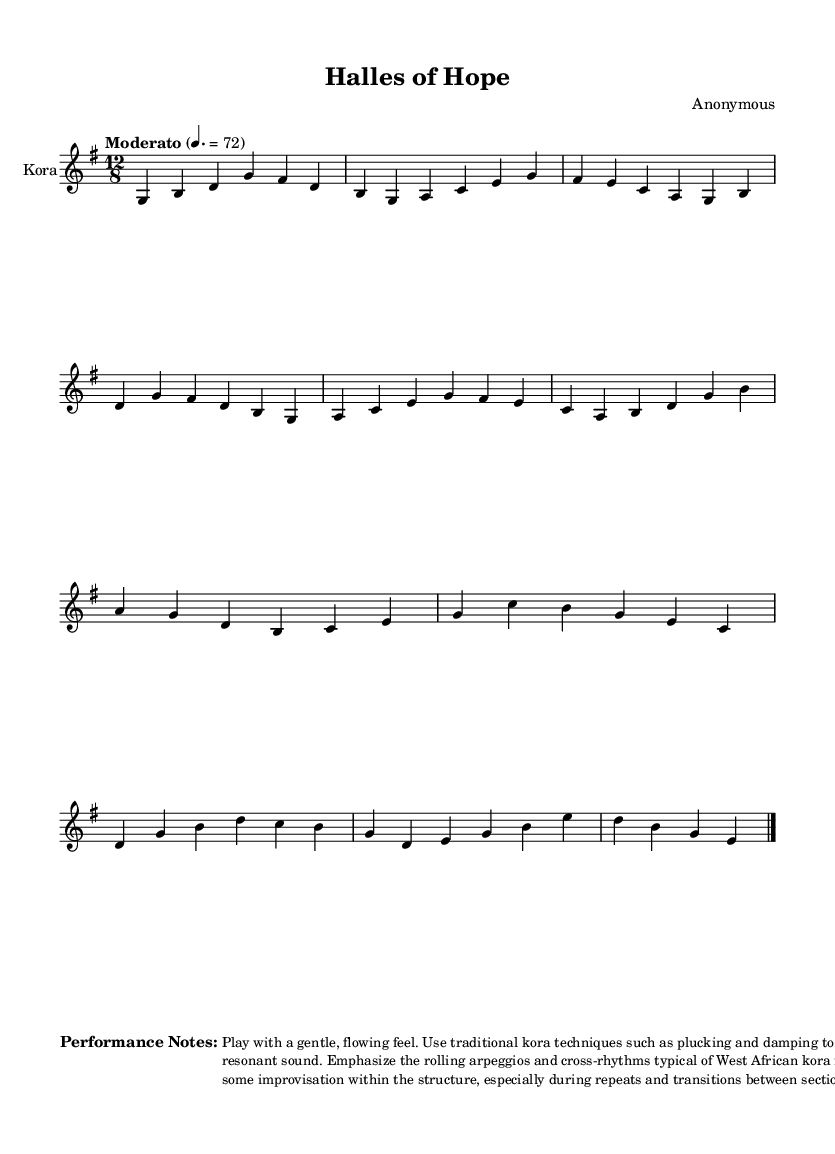What is the key signature of this music? The key signature is G major, which has one sharp (F#). This can be determined by looking at the key signature indicated in the staff.
Answer: G major What is the time signature of this music? The time signature is 12/8, which indicates there are 12 eighth notes per measure. This is visible at the beginning of the sheet music, where the time signature is notated.
Answer: 12/8 What is the tempo marking for this piece? The tempo marking is "Moderato" with a metronome marking of 72 beats per minute, as specified at the beginning of the score.
Answer: Moderato How many measures are in Section A? Section A consists of four measures, which can be counted directly from the notation provided for that section.
Answer: Four What traditional techniques should be used while playing the kora? The performance notes suggest using traditional techniques like plucking and damping, which create the kora's signature sound. This can be read in the performance notes section at the end of the sheet music.
Answer: Plucking and damping What is emphasized in the performance notes regarding the sound? The performance notes emphasize a "warm, resonant sound," which can be found in the instructions for how to play the piece.
Answer: Warm, resonant sound What type of music does this piece represent? This piece represents West African kora music, which is indicated by its instrumentation and stylistic elements common to the genre.
Answer: West African kora music 